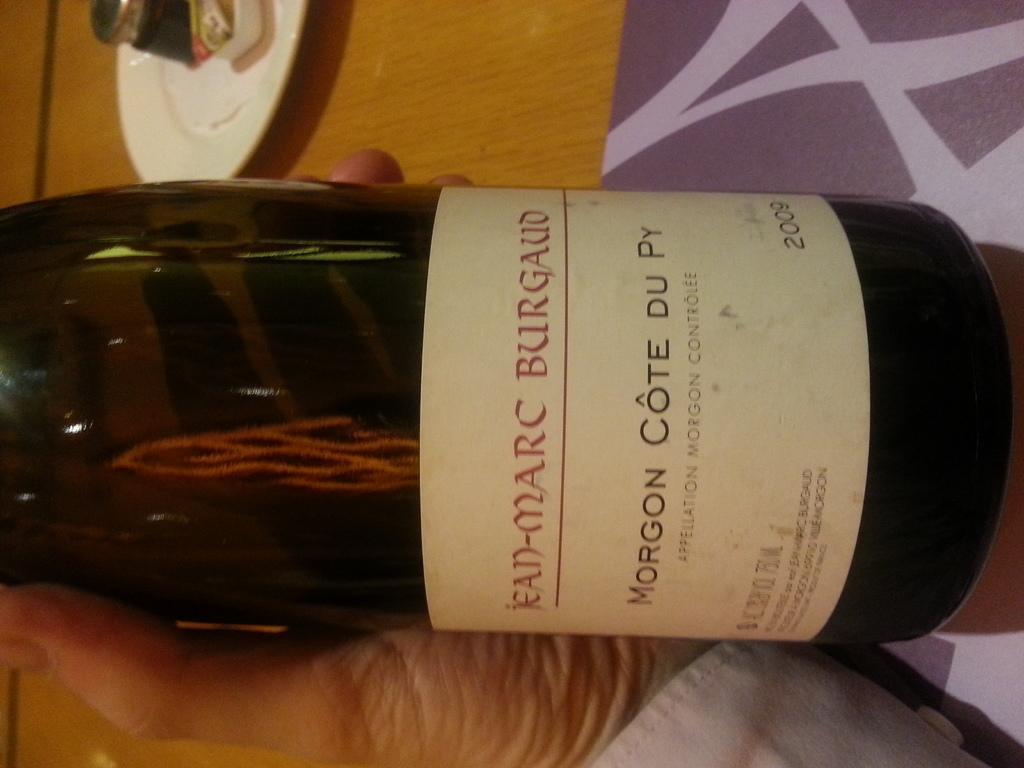Can you describe this image briefly? In this picture I can see a human hand holding a wine bottle and I can see text on the bottle and I can see a plate on the table. 